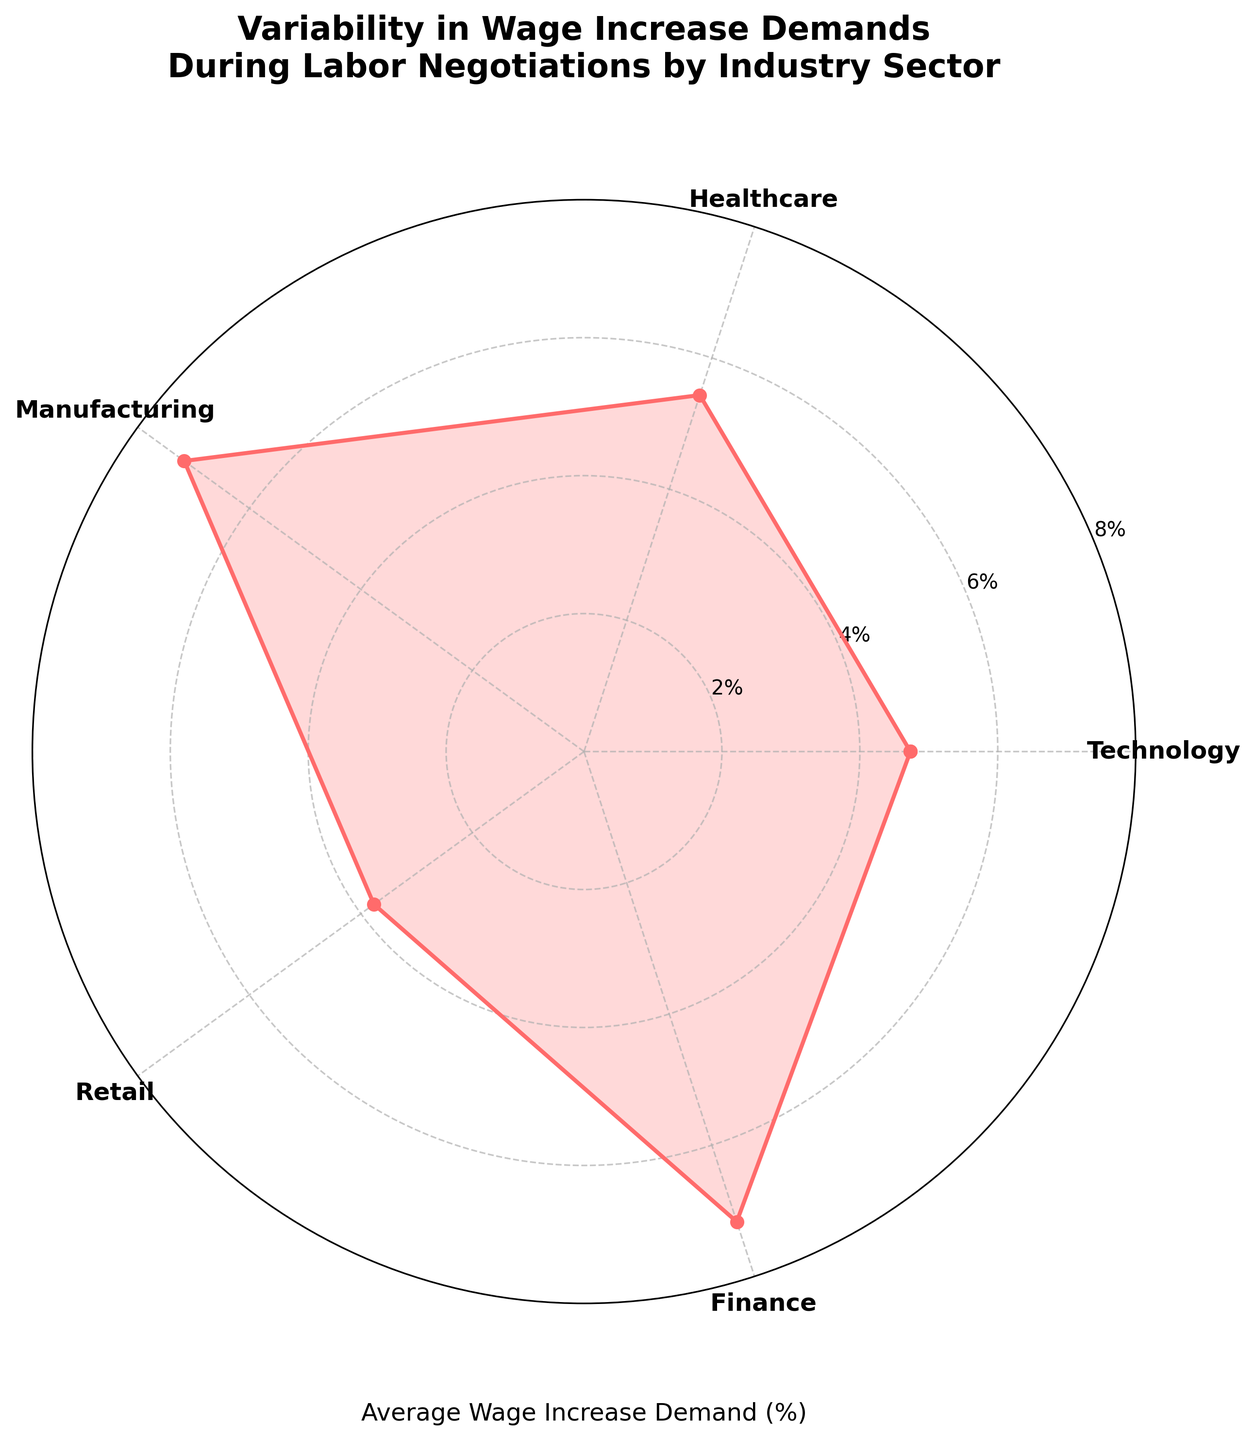Which industry shows the highest average wage increase demand? By looking at the peak points on the plot, the highest average is in the Manufacturing sector.
Answer: Manufacturing Which industry has the lowest average wage increase demand? The lowest point on the plot belongs to the Retail sector.
Answer: Retail How many industry sectors are represented in the chart? Counting the labels around the polar plot gives four sectors: Technology, Healthcare, Manufacturing, and Retail.
Answer: Four What is the average wage increase demand in the Technology sector? The plot peak for Technology is at approximately 7%.
Answer: Around 7% What is the angle corresponding to the Retail sector in the rose chart? Each sector is evenly distributed over 360 degrees, so for four sectors, each sector takes up 90 degrees. Retail, being the fourth from the start, is at 270 degrees.
Answer: 270 degrees Which industries have an average wage increase demand of more than 6%? By checking the plot, both Manufacturing and Technology sectors have averages higher than 6%.
Answer: Technology and Manufacturing How does the average wage increase demand in the Finance sector compare to the Healthcare sector? The plot shows that the average in Healthcare is slightly higher than in Finance.
Answer: Higher in Healthcare What's the difference in average wage increases between the highest and lowest sectors? The Manufacturing sector is about 7.17% and the Retail sector is around 3.77%, giving a difference of about 3.4%.
Answer: About 3.4% What are the two main elements the chart visualizes? The chart visualizes both the average wage increase demand percentage and the industry sectors.
Answer: Average wage increase demand percentage and industry sectors 